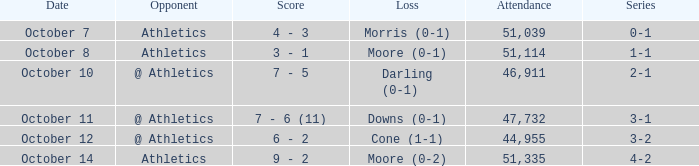When was the contest featuring moore's loss (0-1)? October 8. 